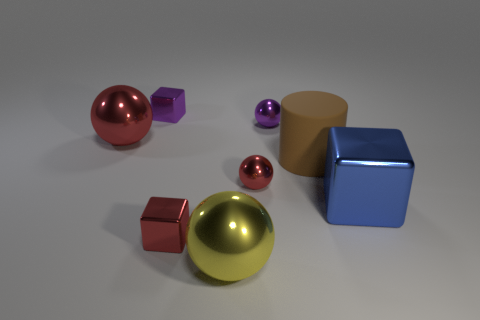Can you describe the shapes and colors of the objects in the image? Certainly! There is a large, reflective yellow ball at the center, a pinkish-red cube and a smaller pinkish-red sphere to its left. On the right, we see a large blue cube, and toward the back, there is a brown cylinder alongside a small purple cube. 